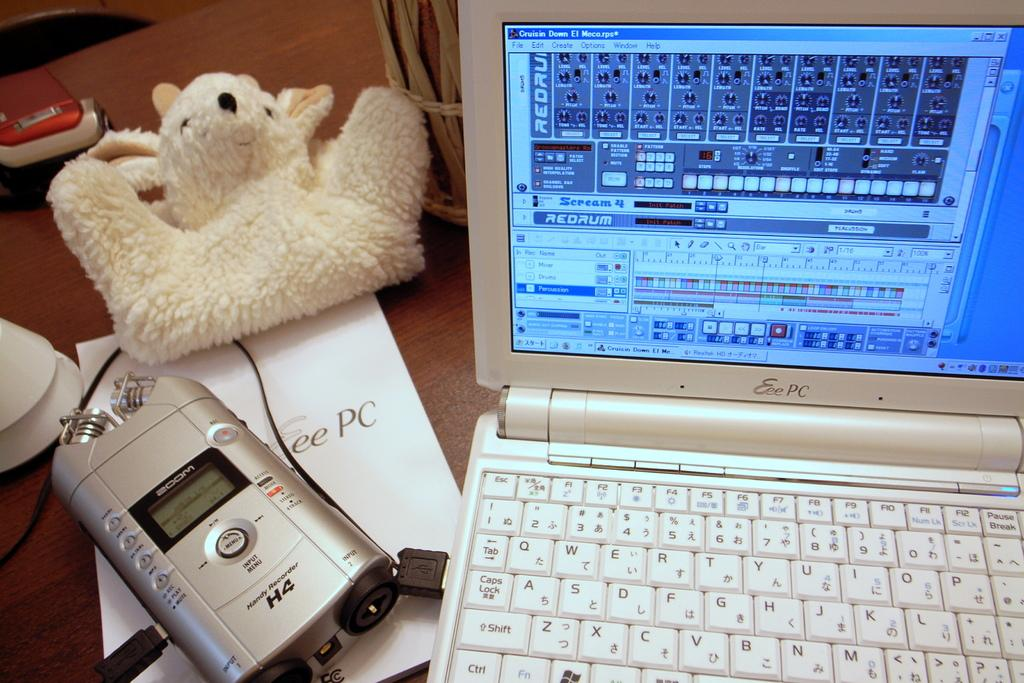<image>
Summarize the visual content of the image. The silver device next to the laptop is a Handy Recorder H4. 